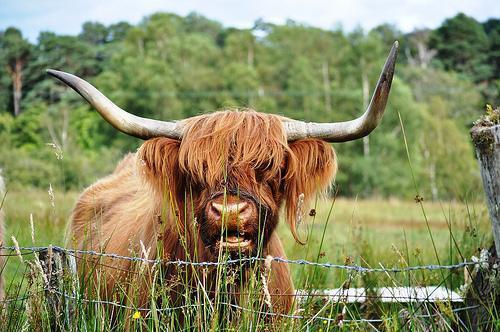How many oxen are in the photo?
Give a very brief answer. 1. 